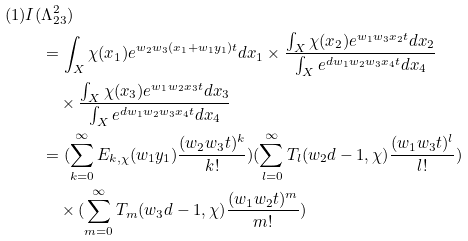<formula> <loc_0><loc_0><loc_500><loc_500>( 1 ) I ( & \Lambda _ { 2 3 } ^ { 2 } ) \\ & = \int _ { X } \chi ( x _ { 1 } ) e ^ { w _ { 2 } w _ { 3 } ( x _ { 1 } + w _ { 1 } y _ { 1 } ) t } d x _ { 1 } \times \frac { \int _ { X } \chi ( x _ { 2 } ) e ^ { w _ { 1 } w _ { 3 } x _ { 2 } t } d x _ { 2 } } { \int _ { X } e ^ { d w _ { 1 } w _ { 2 } w _ { 3 } x _ { 4 } t } d x _ { 4 } } \\ & \quad \times \frac { \int _ { X } \chi ( x _ { 3 } ) e ^ { w _ { 1 } w _ { 2 } x _ { 3 } t } d x _ { 3 } } { \int _ { X } e ^ { d w _ { 1 } w _ { 2 } w _ { 3 } x _ { 4 } t } d x _ { 4 } } \\ & = ( \sum _ { k = 0 } ^ { \infty } E _ { k , \chi } ( w _ { 1 } y _ { 1 } ) \frac { ( w _ { 2 } w _ { 3 } t ) ^ { k } } { k ! } ) ( \sum _ { l = 0 } ^ { \infty } T _ { l } ( w _ { 2 } d - 1 , \chi ) \frac { ( w _ { 1 } w _ { 3 } t ) ^ { l } } { l ! } ) \\ & \quad \times ( \sum _ { m = 0 } ^ { \infty } T _ { m } ( w _ { 3 } d - 1 , \chi ) \frac { ( w _ { 1 } w _ { 2 } t ) ^ { m } } { m ! } ) \\</formula> 